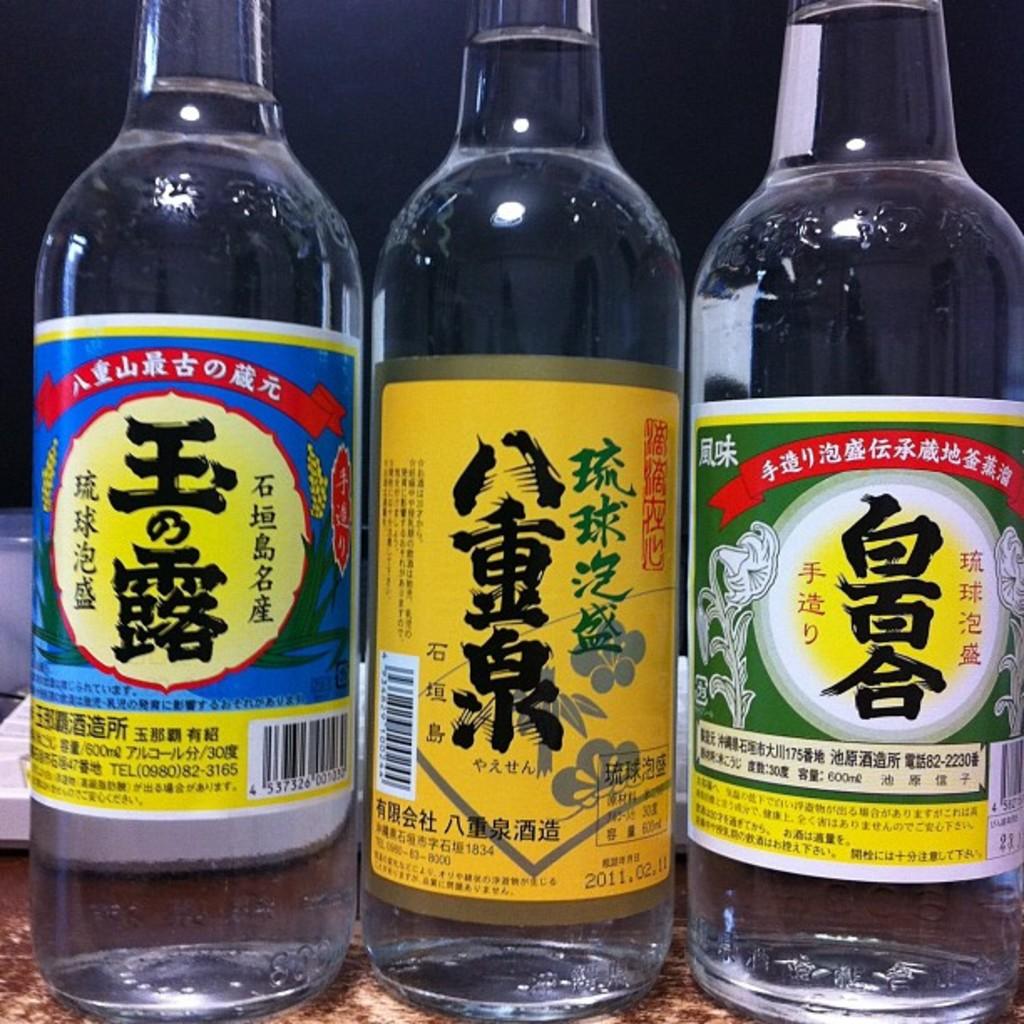What's the year on the middle bottle?  bottom right of the label?
Provide a short and direct response. 2011. 